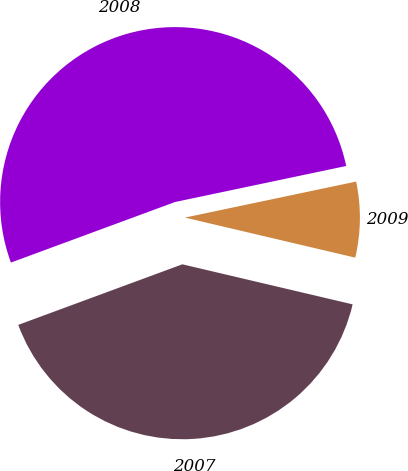Convert chart. <chart><loc_0><loc_0><loc_500><loc_500><pie_chart><fcel>2009<fcel>2008<fcel>2007<nl><fcel>6.98%<fcel>52.33%<fcel>40.7%<nl></chart> 